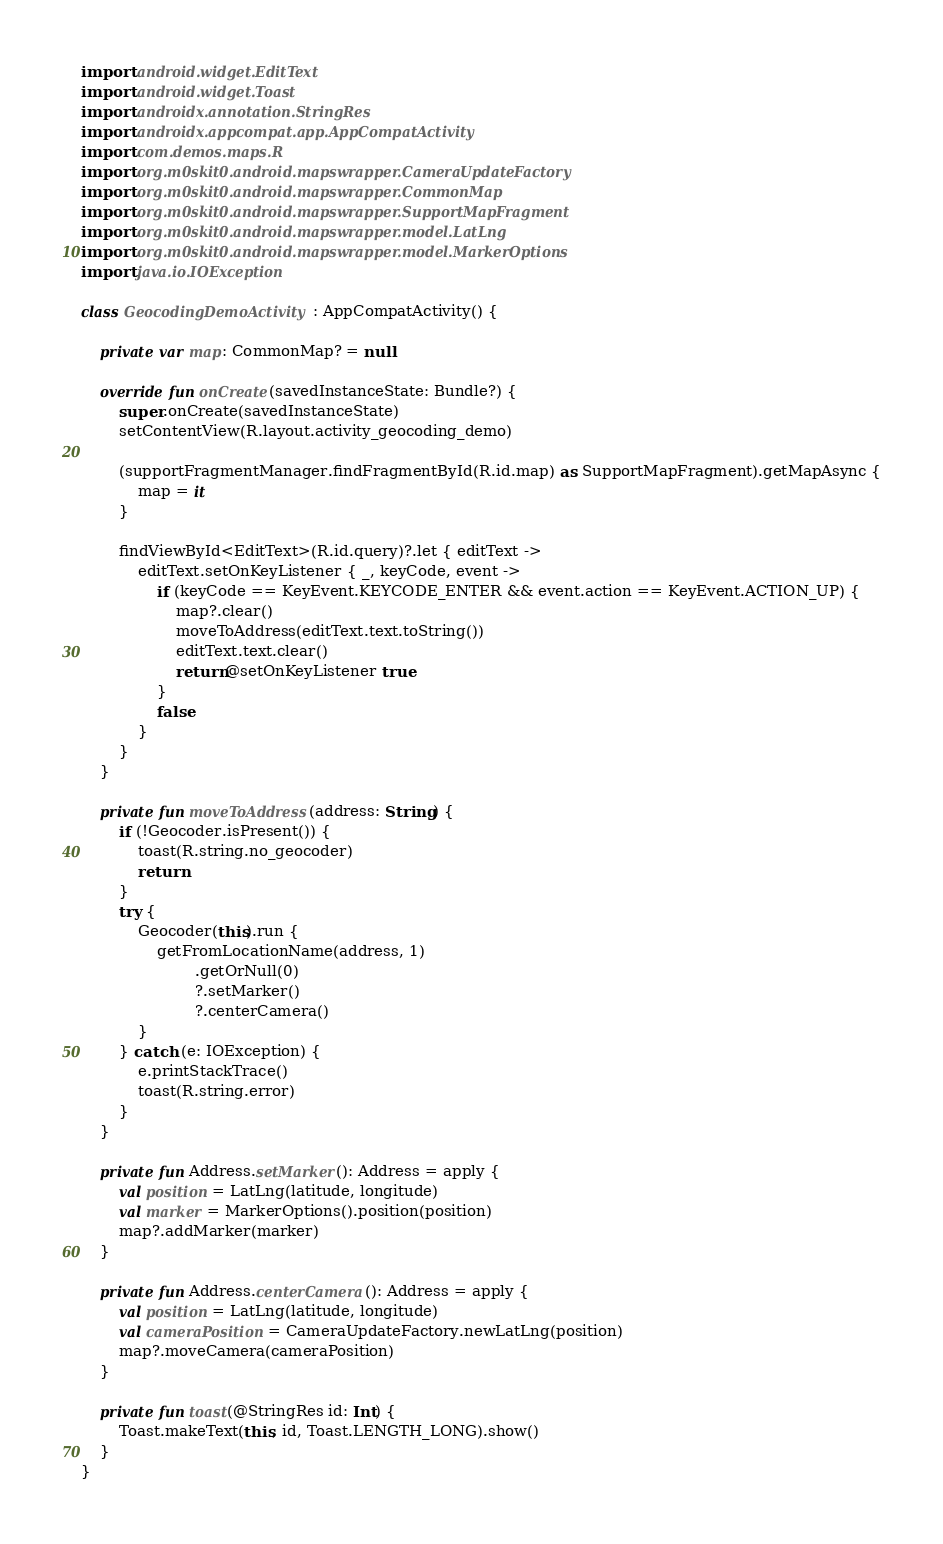<code> <loc_0><loc_0><loc_500><loc_500><_Kotlin_>import android.widget.EditText
import android.widget.Toast
import androidx.annotation.StringRes
import androidx.appcompat.app.AppCompatActivity
import com.demos.maps.R
import org.m0skit0.android.mapswrapper.CameraUpdateFactory
import org.m0skit0.android.mapswrapper.CommonMap
import org.m0skit0.android.mapswrapper.SupportMapFragment
import org.m0skit0.android.mapswrapper.model.LatLng
import org.m0skit0.android.mapswrapper.model.MarkerOptions
import java.io.IOException

class GeocodingDemoActivity : AppCompatActivity() {

    private var map: CommonMap? = null

    override fun onCreate(savedInstanceState: Bundle?) {
        super.onCreate(savedInstanceState)
        setContentView(R.layout.activity_geocoding_demo)

        (supportFragmentManager.findFragmentById(R.id.map) as SupportMapFragment).getMapAsync {
            map = it
        }

        findViewById<EditText>(R.id.query)?.let { editText ->
            editText.setOnKeyListener { _, keyCode, event ->
                if (keyCode == KeyEvent.KEYCODE_ENTER && event.action == KeyEvent.ACTION_UP) {
                    map?.clear()
                    moveToAddress(editText.text.toString())
                    editText.text.clear()
                    return@setOnKeyListener true
                }
                false
            }
        }
    }

    private fun moveToAddress(address: String) {
        if (!Geocoder.isPresent()) {
            toast(R.string.no_geocoder)
            return
        }
        try {
            Geocoder(this).run {
                getFromLocationName(address, 1)
                        .getOrNull(0)
                        ?.setMarker()
                        ?.centerCamera()
            }
        } catch (e: IOException) {
            e.printStackTrace()
            toast(R.string.error)
        }
    }

    private fun Address.setMarker(): Address = apply {
        val position = LatLng(latitude, longitude)
        val marker = MarkerOptions().position(position)
        map?.addMarker(marker)
    }

    private fun Address.centerCamera(): Address = apply {
        val position = LatLng(latitude, longitude)
        val cameraPosition = CameraUpdateFactory.newLatLng(position)
        map?.moveCamera(cameraPosition)
    }

    private fun toast(@StringRes id: Int) {
        Toast.makeText(this, id, Toast.LENGTH_LONG).show()
    }
}
</code> 